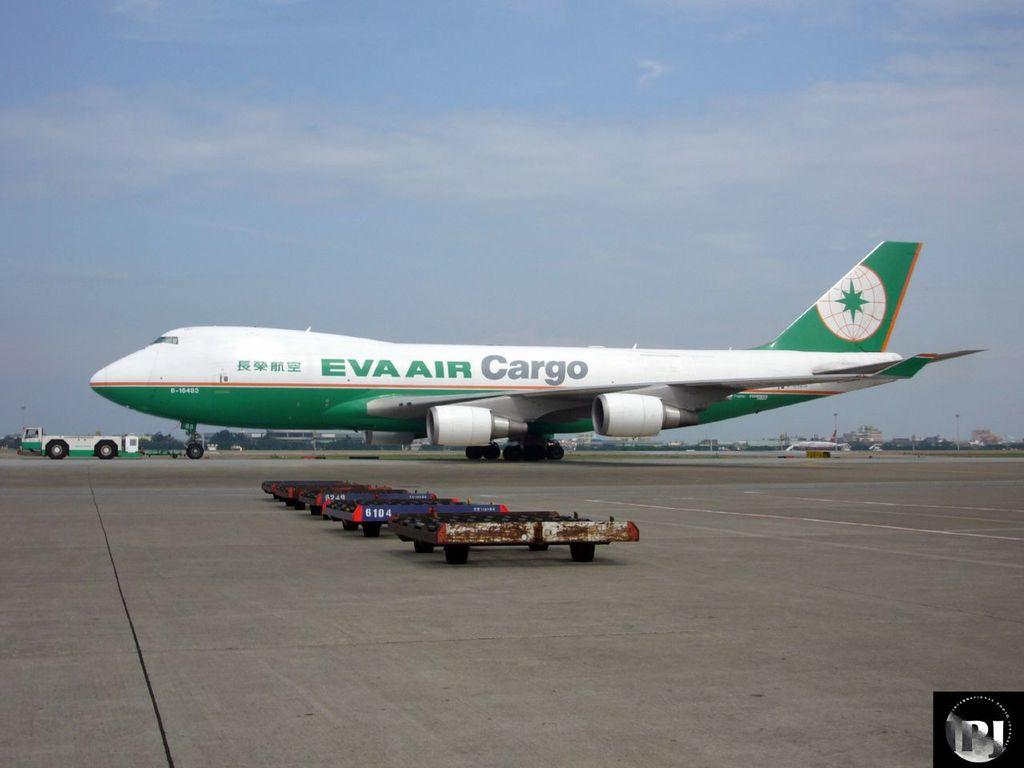<image>
Summarize the visual content of the image. A large aeroplane with the words EVA AIR CARGO on it 